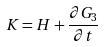<formula> <loc_0><loc_0><loc_500><loc_500>K = H + \frac { \partial G _ { 3 } } { \partial t }</formula> 